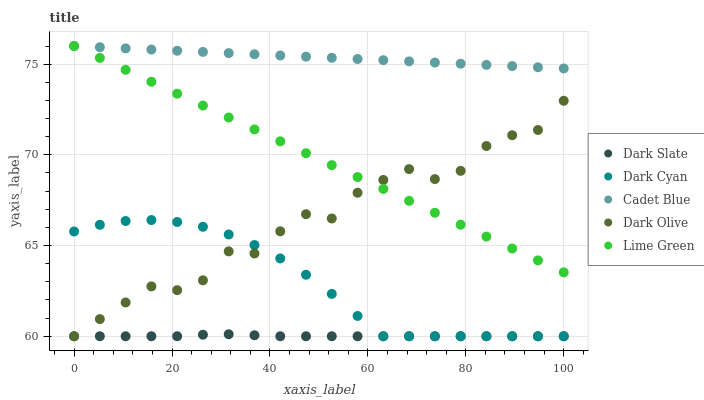Does Dark Slate have the minimum area under the curve?
Answer yes or no. Yes. Does Cadet Blue have the maximum area under the curve?
Answer yes or no. Yes. Does Cadet Blue have the minimum area under the curve?
Answer yes or no. No. Does Dark Slate have the maximum area under the curve?
Answer yes or no. No. Is Cadet Blue the smoothest?
Answer yes or no. Yes. Is Dark Olive the roughest?
Answer yes or no. Yes. Is Dark Slate the smoothest?
Answer yes or no. No. Is Dark Slate the roughest?
Answer yes or no. No. Does Dark Cyan have the lowest value?
Answer yes or no. Yes. Does Cadet Blue have the lowest value?
Answer yes or no. No. Does Lime Green have the highest value?
Answer yes or no. Yes. Does Dark Slate have the highest value?
Answer yes or no. No. Is Dark Slate less than Cadet Blue?
Answer yes or no. Yes. Is Cadet Blue greater than Dark Cyan?
Answer yes or no. Yes. Does Dark Olive intersect Dark Slate?
Answer yes or no. Yes. Is Dark Olive less than Dark Slate?
Answer yes or no. No. Is Dark Olive greater than Dark Slate?
Answer yes or no. No. Does Dark Slate intersect Cadet Blue?
Answer yes or no. No. 